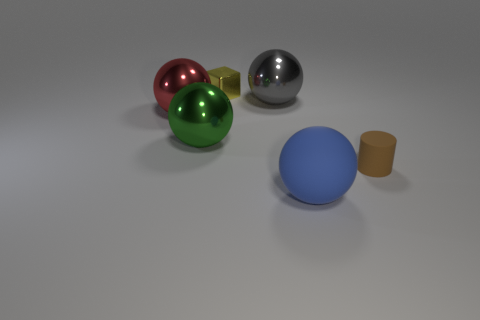Are the objects arranged in a particular pattern or order? The objects do not follow a strict pattern but are placed in a way that creates a balanced composition. The varying sizes and distances between them might be indicative of an artistic intent to portray harmony and contrast through simple geometric forms. 